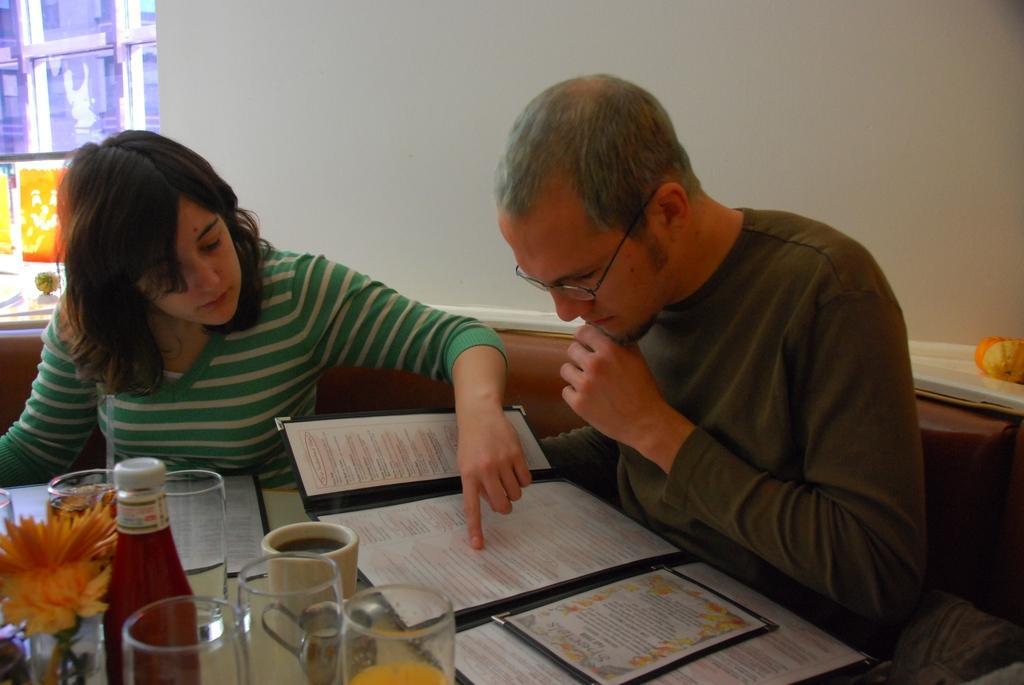Please provide a concise description of this image. In this image I can see a person wearing a t-shirt and glasses is sitting on the couch and a woman wearing a green dress sitting on the couch in front of a table, on the table i can see the menu, few glasses, a bottle, a flower and a cup, in the background I can see the wall and the window. 